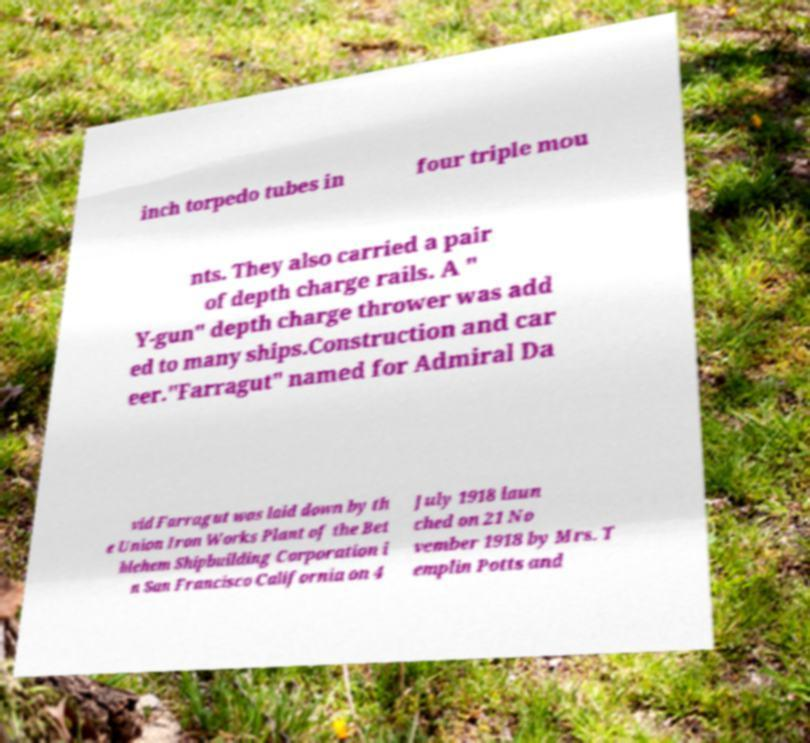Please identify and transcribe the text found in this image. inch torpedo tubes in four triple mou nts. They also carried a pair of depth charge rails. A " Y-gun" depth charge thrower was add ed to many ships.Construction and car eer."Farragut" named for Admiral Da vid Farragut was laid down by th e Union Iron Works Plant of the Bet hlehem Shipbuilding Corporation i n San Francisco California on 4 July 1918 laun ched on 21 No vember 1918 by Mrs. T emplin Potts and 